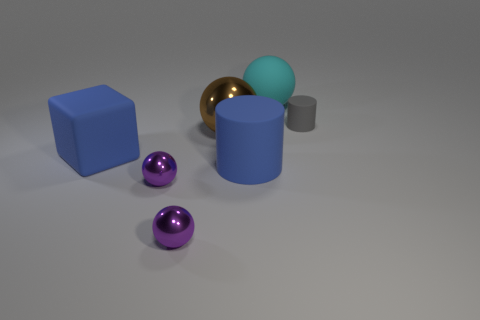Subtract 1 spheres. How many spheres are left? 3 Subtract all metal balls. How many balls are left? 1 Add 1 large rubber cylinders. How many objects exist? 8 Subtract all brown spheres. How many spheres are left? 3 Subtract all red spheres. Subtract all green cubes. How many spheres are left? 4 Subtract all cubes. How many objects are left? 6 Subtract all large cyan matte objects. Subtract all tiny blue matte balls. How many objects are left? 6 Add 7 cubes. How many cubes are left? 8 Add 3 cyan rubber spheres. How many cyan rubber spheres exist? 4 Subtract 0 yellow blocks. How many objects are left? 7 